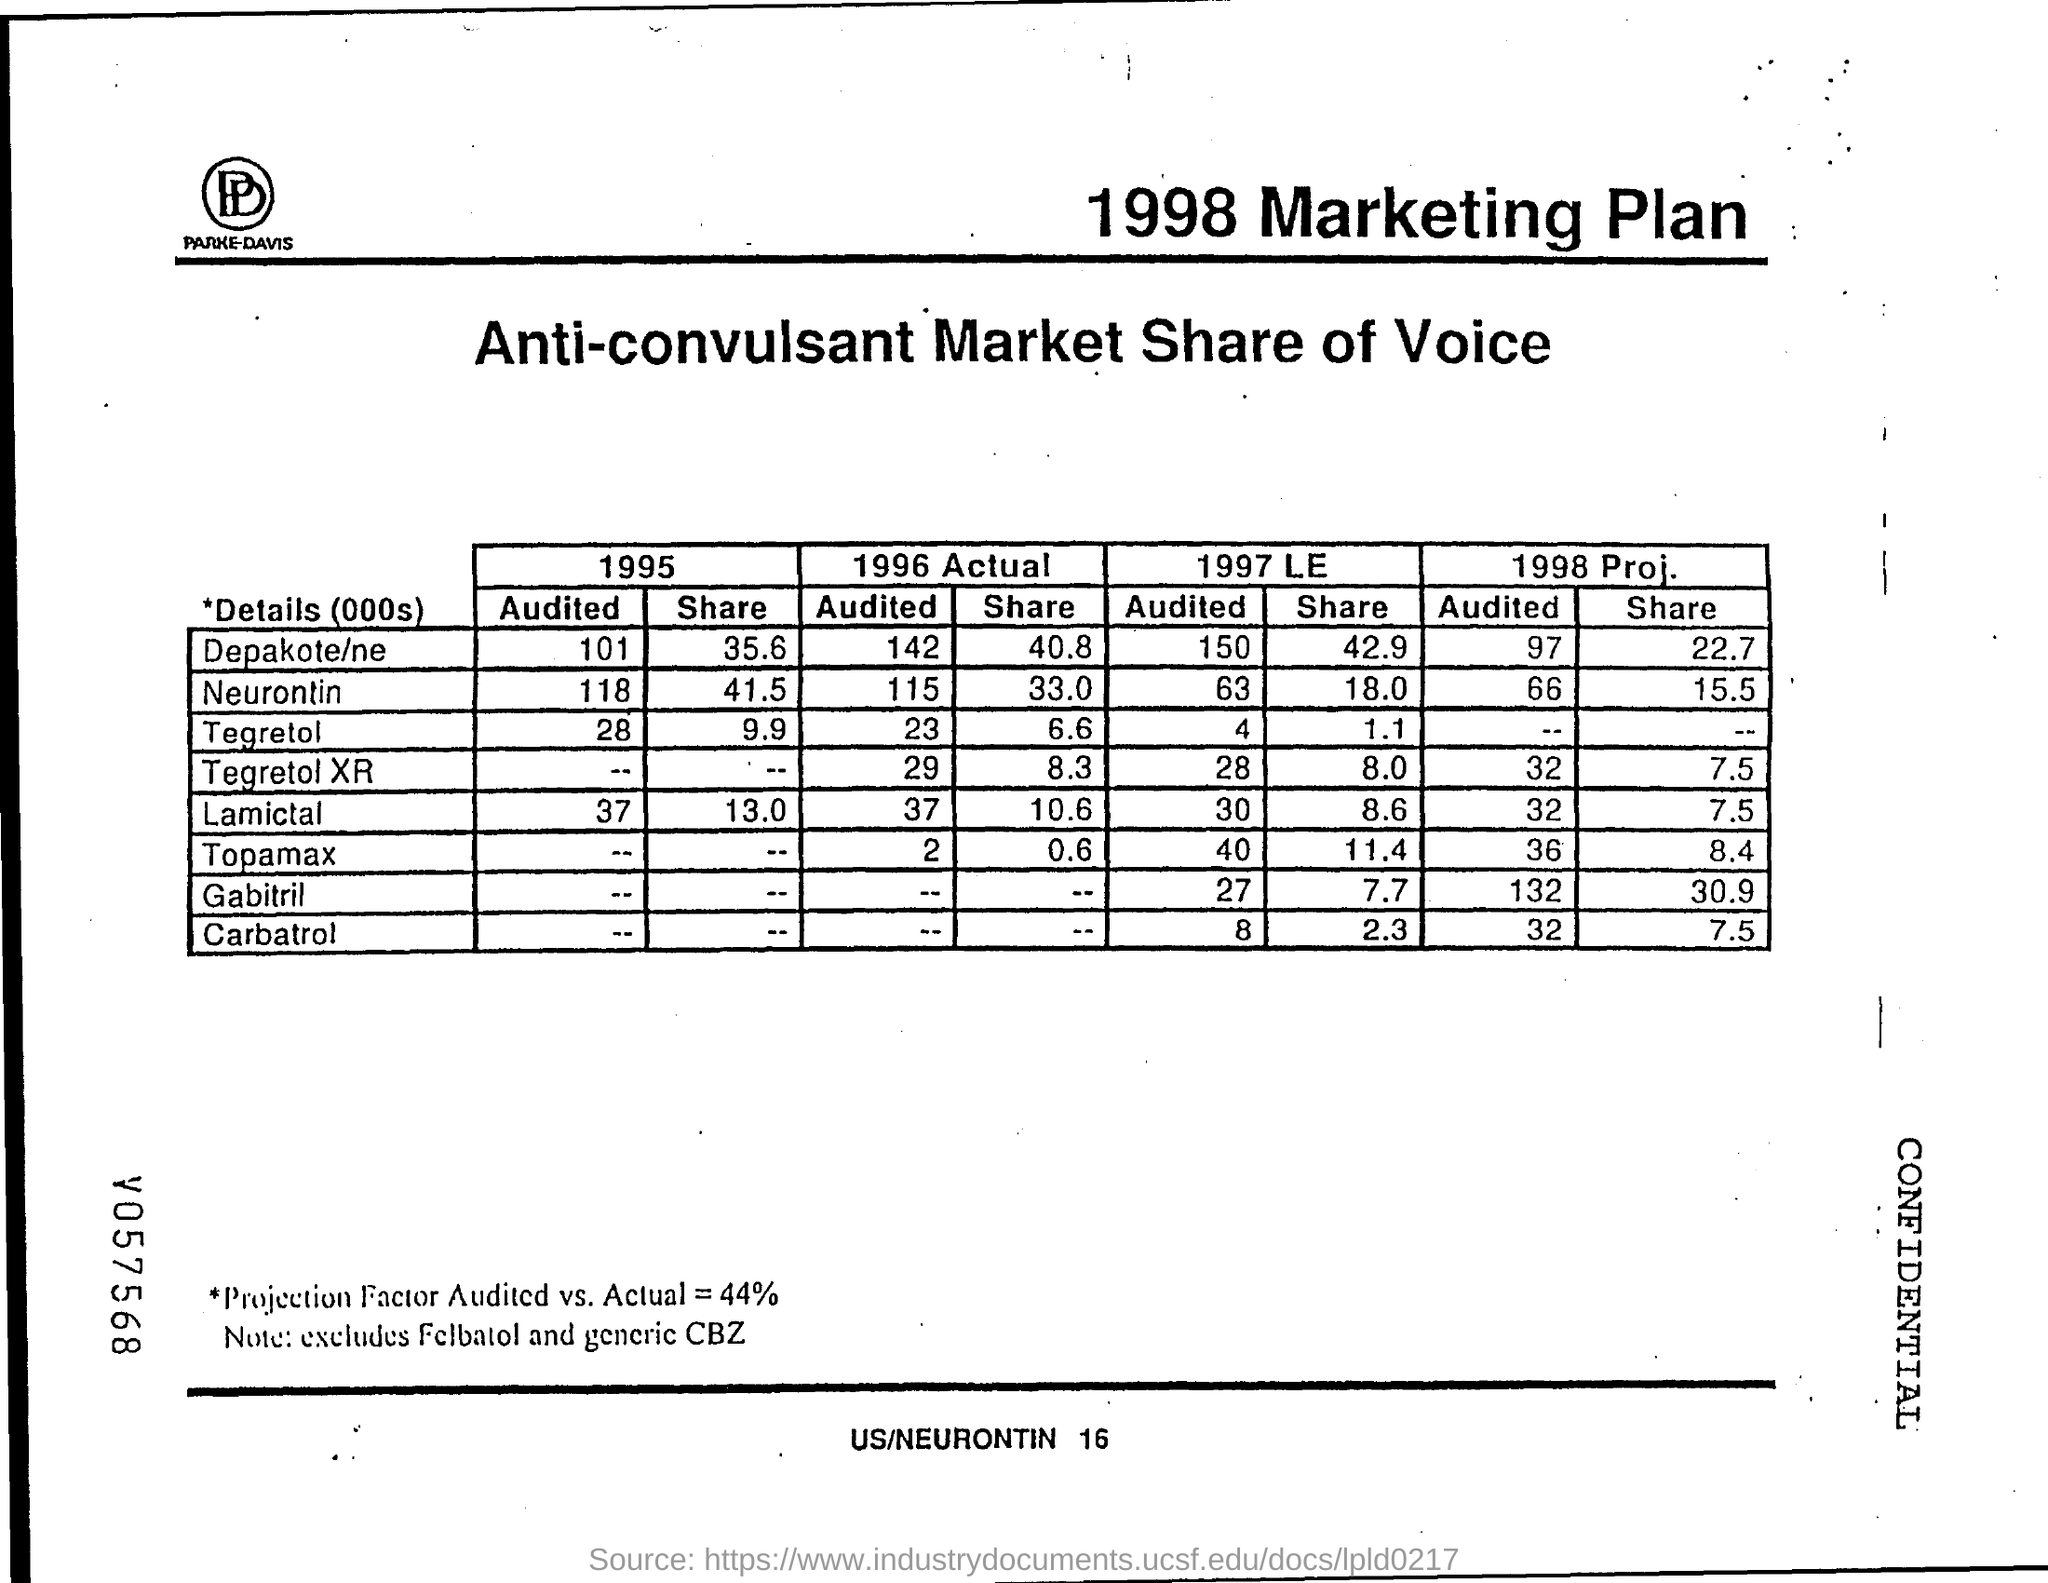What is the Depakote/ne "audited" value for 1995?
Your response must be concise. 101. What is the Neurontin "audited" value for 1995?
Your response must be concise. 118. What is the Tegretol "audited" value for 1995?
Make the answer very short. 28. What is the Lamictal "audited" value for 1995?
Offer a terse response. 37. What is the Depakote/ne "Share" value for 1995?
Keep it short and to the point. 35.6. What is the Neurontin "share" value for 1995?
Offer a terse response. 41.5. What is the Tegretol "share" value for 1995?
Keep it short and to the point. 9.9. What is the Lamictal "share" value for 1995?
Provide a short and direct response. 13. What is the Lamictal "audited" value for 1996 actual?
Your answer should be compact. 37. 